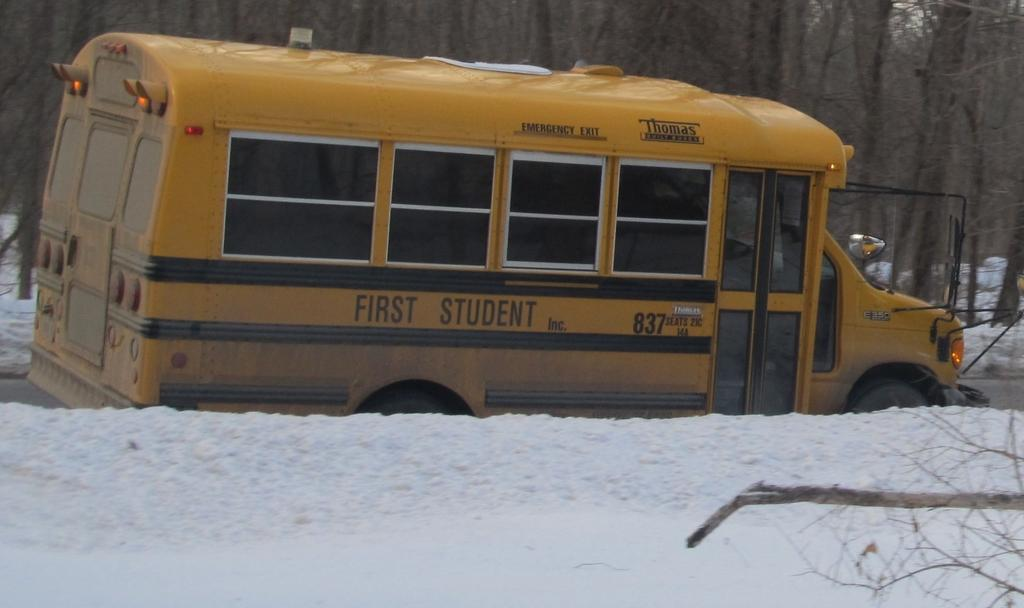<image>
Render a clear and concise summary of the photo. A medium sized school bus, number 837, First Student Inc, on a snow plowed road. 